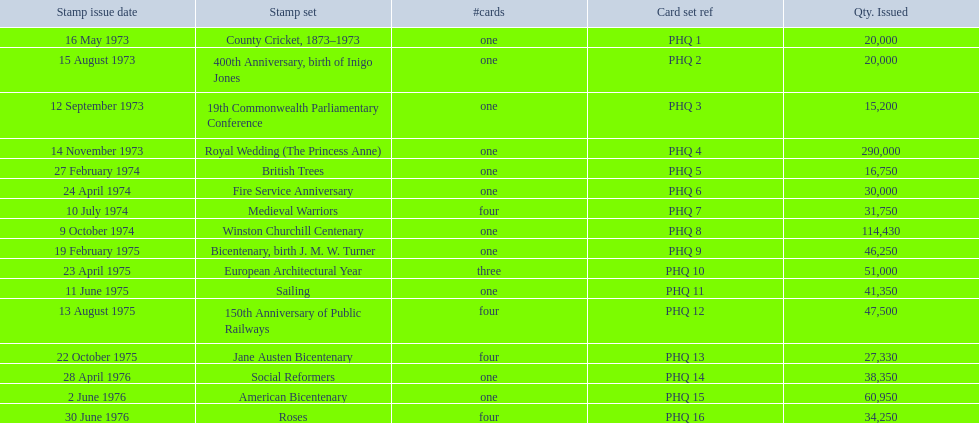What are all of the stamp sets? County Cricket, 1873–1973, 400th Anniversary, birth of Inigo Jones, 19th Commonwealth Parliamentary Conference, Royal Wedding (The Princess Anne), British Trees, Fire Service Anniversary, Medieval Warriors, Winston Churchill Centenary, Bicentenary, birth J. M. W. Turner, European Architectural Year, Sailing, 150th Anniversary of Public Railways, Jane Austen Bicentenary, Social Reformers, American Bicentenary, Roses. Which of these sets has three cards in it? European Architectural Year. I'm looking to parse the entire table for insights. Could you assist me with that? {'header': ['Stamp issue date', 'Stamp set', '#cards', 'Card set ref', 'Qty. Issued'], 'rows': [['16 May 1973', 'County Cricket, 1873–1973', 'one', 'PHQ 1', '20,000'], ['15 August 1973', '400th Anniversary, birth of Inigo Jones', 'one', 'PHQ 2', '20,000'], ['12 September 1973', '19th Commonwealth Parliamentary Conference', 'one', 'PHQ 3', '15,200'], ['14 November 1973', 'Royal Wedding (The Princess Anne)', 'one', 'PHQ 4', '290,000'], ['27 February 1974', 'British Trees', 'one', 'PHQ 5', '16,750'], ['24 April 1974', 'Fire Service Anniversary', 'one', 'PHQ 6', '30,000'], ['10 July 1974', 'Medieval Warriors', 'four', 'PHQ 7', '31,750'], ['9 October 1974', 'Winston Churchill Centenary', 'one', 'PHQ 8', '114,430'], ['19 February 1975', 'Bicentenary, birth J. M. W. Turner', 'one', 'PHQ 9', '46,250'], ['23 April 1975', 'European Architectural Year', 'three', 'PHQ 10', '51,000'], ['11 June 1975', 'Sailing', 'one', 'PHQ 11', '41,350'], ['13 August 1975', '150th Anniversary of Public Railways', 'four', 'PHQ 12', '47,500'], ['22 October 1975', 'Jane Austen Bicentenary', 'four', 'PHQ 13', '27,330'], ['28 April 1976', 'Social Reformers', 'one', 'PHQ 14', '38,350'], ['2 June 1976', 'American Bicentenary', 'one', 'PHQ 15', '60,950'], ['30 June 1976', 'Roses', 'four', 'PHQ 16', '34,250']]} 